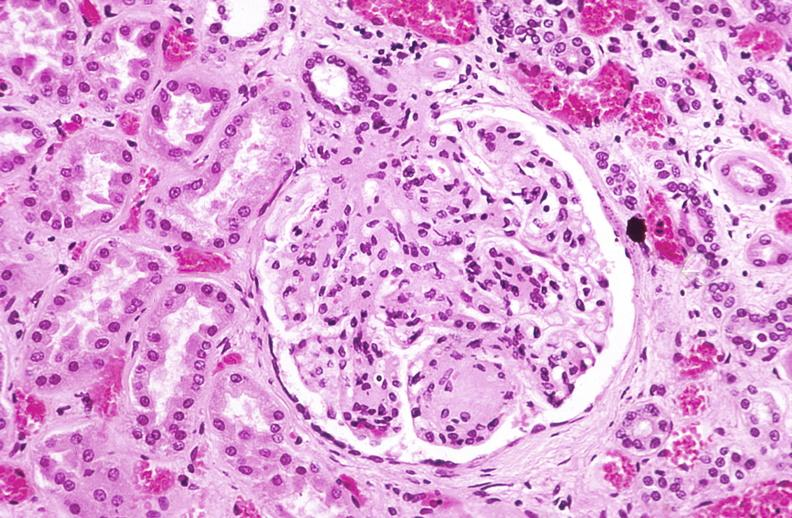does this image show kidney glomerulus, kimmelstiel-wilson nodules in a patient with diabetes mellitus?
Answer the question using a single word or phrase. Yes 